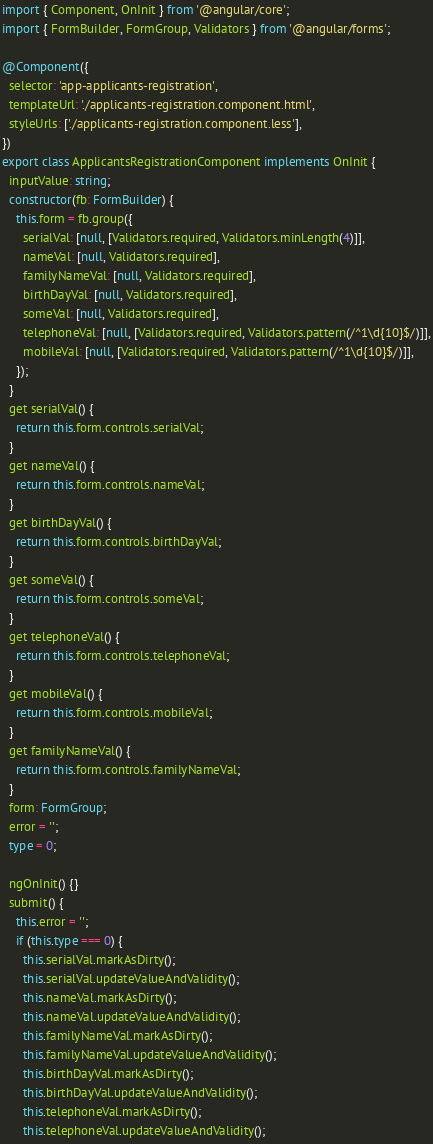Convert code to text. <code><loc_0><loc_0><loc_500><loc_500><_TypeScript_>import { Component, OnInit } from '@angular/core';
import { FormBuilder, FormGroup, Validators } from '@angular/forms';

@Component({
  selector: 'app-applicants-registration',
  templateUrl: './applicants-registration.component.html',
  styleUrls: ['./applicants-registration.component.less'],
})
export class ApplicantsRegistrationComponent implements OnInit {
  inputValue: string;
  constructor(fb: FormBuilder) {
    this.form = fb.group({
      serialVal: [null, [Validators.required, Validators.minLength(4)]],
      nameVal: [null, Validators.required],
      familyNameVal: [null, Validators.required],
      birthDayVal: [null, Validators.required],
      someVal: [null, Validators.required],
      telephoneVal: [null, [Validators.required, Validators.pattern(/^1\d{10}$/)]],
      mobileVal: [null, [Validators.required, Validators.pattern(/^1\d{10}$/)]],
    });
  }
  get serialVal() {
    return this.form.controls.serialVal;
  }
  get nameVal() {
    return this.form.controls.nameVal;
  }
  get birthDayVal() {
    return this.form.controls.birthDayVal;
  }
  get someVal() {
    return this.form.controls.someVal;
  }
  get telephoneVal() {
    return this.form.controls.telephoneVal;
  }
  get mobileVal() {
    return this.form.controls.mobileVal;
  }
  get familyNameVal() {
    return this.form.controls.familyNameVal;
  }
  form: FormGroup;
  error = '';
  type = 0;

  ngOnInit() {}
  submit() {
    this.error = '';
    if (this.type === 0) {
      this.serialVal.markAsDirty();
      this.serialVal.updateValueAndValidity();
      this.nameVal.markAsDirty();
      this.nameVal.updateValueAndValidity();
      this.familyNameVal.markAsDirty();
      this.familyNameVal.updateValueAndValidity();
      this.birthDayVal.markAsDirty();
      this.birthDayVal.updateValueAndValidity();
      this.telephoneVal.markAsDirty();
      this.telephoneVal.updateValueAndValidity();</code> 